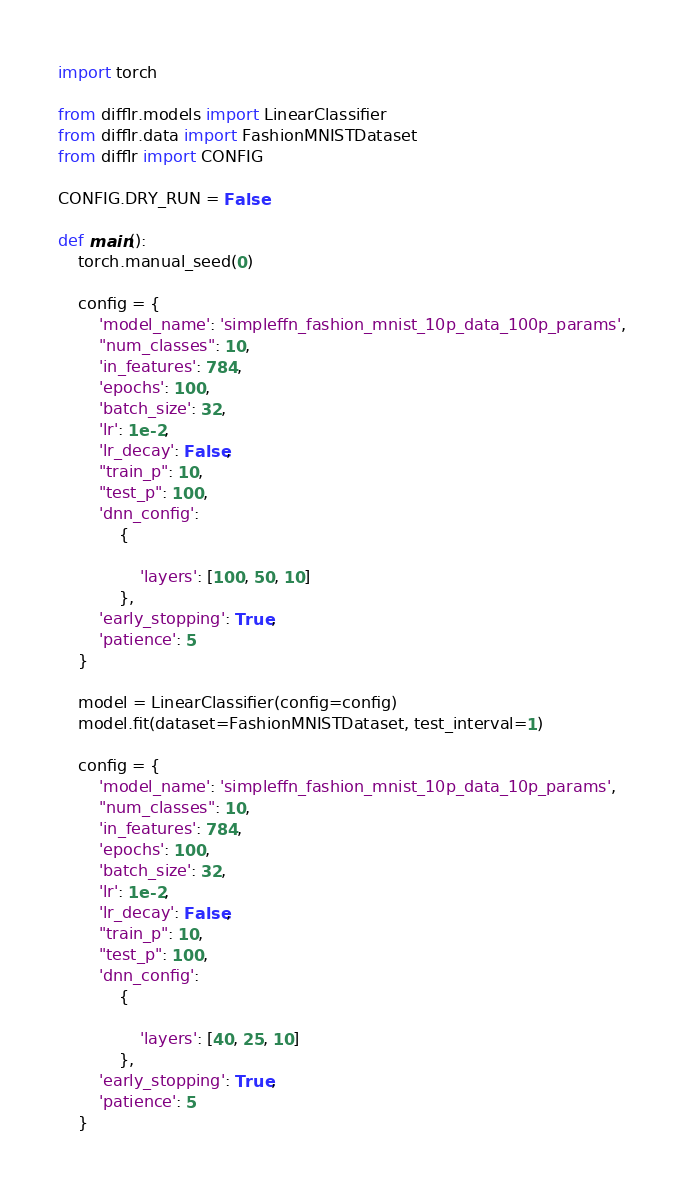<code> <loc_0><loc_0><loc_500><loc_500><_Python_>import torch

from difflr.models import LinearClassifier
from difflr.data import FashionMNISTDataset
from difflr import CONFIG

CONFIG.DRY_RUN = False

def main():
    torch.manual_seed(0)

    config = {
        'model_name': 'simpleffn_fashion_mnist_10p_data_100p_params',
        "num_classes": 10,
        'in_features': 784,
        'epochs': 100,
        'batch_size': 32,
        'lr': 1e-2,
        'lr_decay': False,
        "train_p": 10,
        "test_p": 100,
        'dnn_config':
            {

                'layers': [100, 50, 10]
            },
        'early_stopping': True,
        'patience': 5
    }

    model = LinearClassifier(config=config)
    model.fit(dataset=FashionMNISTDataset, test_interval=1)

    config = {
        'model_name': 'simpleffn_fashion_mnist_10p_data_10p_params',
        "num_classes": 10,
        'in_features': 784,
        'epochs': 100,
        'batch_size': 32,
        'lr': 1e-2,
        'lr_decay': False,
        "train_p": 10,
        "test_p": 100,
        'dnn_config':
            {

                'layers': [40, 25, 10]
            },
        'early_stopping': True,
        'patience': 5
    }
</code> 